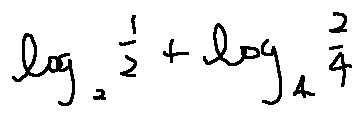Convert formula to latex. <formula><loc_0><loc_0><loc_500><loc_500>\log _ { 2 } \frac { 1 } { 2 } + \log _ { 4 } \frac { 2 } { 4 }</formula> 